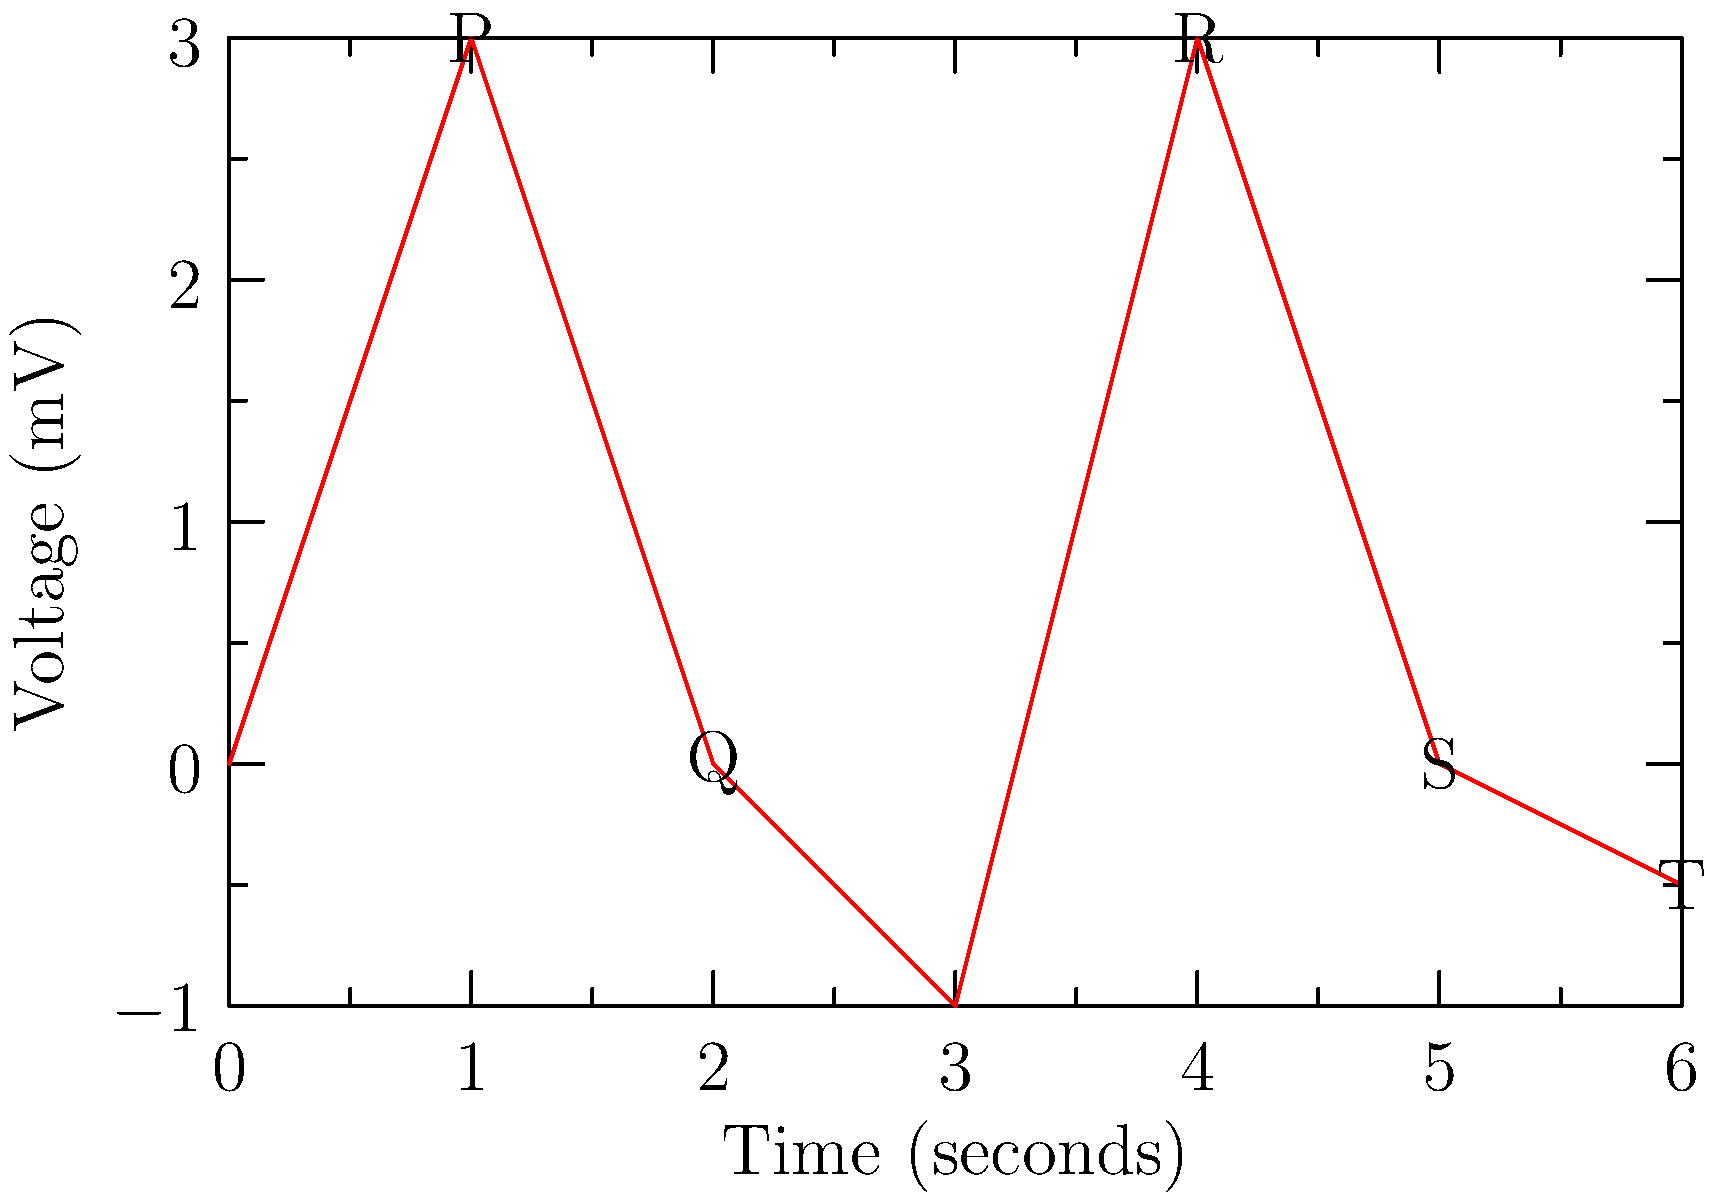In the ECG graph shown above, which wave represents ventricular depolarization? To answer this question, let's break down the components of a typical ECG waveform:

1. P wave: Represents atrial depolarization
2. QRS complex: Consists of Q, R, and S waves
3. T wave: Represents ventricular repolarization

The QRS complex, specifically the R wave, represents ventricular depolarization. Here's why:

1. The P wave (first positive deflection) represents atrial depolarization.
2. The QRS complex follows the P wave and consists of:
   a. Q wave: small downward deflection
   b. R wave: large upward deflection
   c. S wave: downward deflection following the R wave
3. The T wave (final wave) represents ventricular repolarization.

In the given ECG, the R wave is the tall, positive deflection occurring at approximately 4 seconds on the time axis. This prominent spike represents the rapid depolarization of the ventricles, which leads to their contraction.

Therefore, the R wave, which is part of the QRS complex, represents ventricular depolarization.
Answer: R wave 